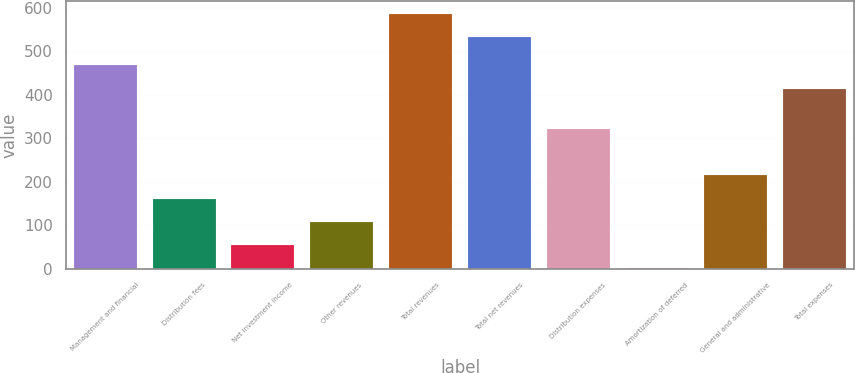<chart> <loc_0><loc_0><loc_500><loc_500><bar_chart><fcel>Management and financial<fcel>Distribution fees<fcel>Net investment income<fcel>Other revenues<fcel>Total revenues<fcel>Total net revenues<fcel>Distribution expenses<fcel>Amortization of deferred<fcel>General and administrative<fcel>Total expenses<nl><fcel>467.3<fcel>160.9<fcel>54.3<fcel>107.6<fcel>585.3<fcel>532<fcel>320.8<fcel>1<fcel>214.2<fcel>414<nl></chart> 